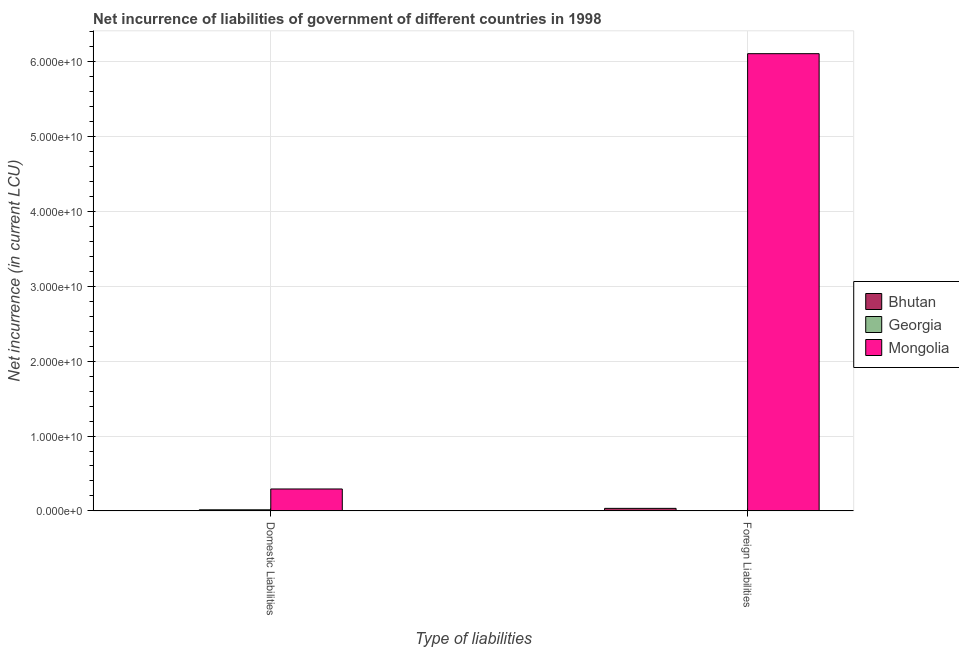Are the number of bars per tick equal to the number of legend labels?
Ensure brevity in your answer.  No. How many bars are there on the 2nd tick from the left?
Offer a very short reply. 3. How many bars are there on the 2nd tick from the right?
Keep it short and to the point. 2. What is the label of the 2nd group of bars from the left?
Provide a succinct answer. Foreign Liabilities. What is the net incurrence of domestic liabilities in Georgia?
Your answer should be very brief. 1.46e+08. Across all countries, what is the maximum net incurrence of domestic liabilities?
Offer a terse response. 2.93e+09. Across all countries, what is the minimum net incurrence of foreign liabilities?
Your response must be concise. 2.99e+07. In which country was the net incurrence of foreign liabilities maximum?
Keep it short and to the point. Mongolia. What is the total net incurrence of domestic liabilities in the graph?
Provide a short and direct response. 3.07e+09. What is the difference between the net incurrence of foreign liabilities in Georgia and that in Bhutan?
Make the answer very short. -3.06e+08. What is the difference between the net incurrence of foreign liabilities in Mongolia and the net incurrence of domestic liabilities in Georgia?
Offer a terse response. 6.09e+1. What is the average net incurrence of domestic liabilities per country?
Give a very brief answer. 1.02e+09. What is the difference between the net incurrence of foreign liabilities and net incurrence of domestic liabilities in Mongolia?
Offer a very short reply. 5.82e+1. What is the ratio of the net incurrence of foreign liabilities in Mongolia to that in Georgia?
Provide a short and direct response. 2042.94. Is the net incurrence of foreign liabilities in Mongolia less than that in Bhutan?
Make the answer very short. No. In how many countries, is the net incurrence of foreign liabilities greater than the average net incurrence of foreign liabilities taken over all countries?
Ensure brevity in your answer.  1. Are all the bars in the graph horizontal?
Give a very brief answer. No. What is the difference between two consecutive major ticks on the Y-axis?
Ensure brevity in your answer.  1.00e+1. Does the graph contain any zero values?
Offer a very short reply. Yes. How are the legend labels stacked?
Your answer should be very brief. Vertical. What is the title of the graph?
Give a very brief answer. Net incurrence of liabilities of government of different countries in 1998. Does "Malta" appear as one of the legend labels in the graph?
Your response must be concise. No. What is the label or title of the X-axis?
Your answer should be compact. Type of liabilities. What is the label or title of the Y-axis?
Your answer should be compact. Net incurrence (in current LCU). What is the Net incurrence (in current LCU) in Bhutan in Domestic Liabilities?
Offer a terse response. 0. What is the Net incurrence (in current LCU) in Georgia in Domestic Liabilities?
Make the answer very short. 1.46e+08. What is the Net incurrence (in current LCU) in Mongolia in Domestic Liabilities?
Ensure brevity in your answer.  2.93e+09. What is the Net incurrence (in current LCU) of Bhutan in Foreign Liabilities?
Offer a terse response. 3.36e+08. What is the Net incurrence (in current LCU) of Georgia in Foreign Liabilities?
Offer a very short reply. 2.99e+07. What is the Net incurrence (in current LCU) of Mongolia in Foreign Liabilities?
Your answer should be compact. 6.11e+1. Across all Type of liabilities, what is the maximum Net incurrence (in current LCU) in Bhutan?
Your answer should be very brief. 3.36e+08. Across all Type of liabilities, what is the maximum Net incurrence (in current LCU) in Georgia?
Offer a terse response. 1.46e+08. Across all Type of liabilities, what is the maximum Net incurrence (in current LCU) of Mongolia?
Offer a terse response. 6.11e+1. Across all Type of liabilities, what is the minimum Net incurrence (in current LCU) in Bhutan?
Your answer should be compact. 0. Across all Type of liabilities, what is the minimum Net incurrence (in current LCU) of Georgia?
Your answer should be very brief. 2.99e+07. Across all Type of liabilities, what is the minimum Net incurrence (in current LCU) in Mongolia?
Give a very brief answer. 2.93e+09. What is the total Net incurrence (in current LCU) of Bhutan in the graph?
Offer a terse response. 3.36e+08. What is the total Net incurrence (in current LCU) of Georgia in the graph?
Provide a succinct answer. 1.75e+08. What is the total Net incurrence (in current LCU) in Mongolia in the graph?
Your answer should be compact. 6.40e+1. What is the difference between the Net incurrence (in current LCU) of Georgia in Domestic Liabilities and that in Foreign Liabilities?
Give a very brief answer. 1.16e+08. What is the difference between the Net incurrence (in current LCU) of Mongolia in Domestic Liabilities and that in Foreign Liabilities?
Offer a terse response. -5.82e+1. What is the difference between the Net incurrence (in current LCU) of Georgia in Domestic Liabilities and the Net incurrence (in current LCU) of Mongolia in Foreign Liabilities?
Give a very brief answer. -6.09e+1. What is the average Net incurrence (in current LCU) in Bhutan per Type of liabilities?
Your answer should be compact. 1.68e+08. What is the average Net incurrence (in current LCU) of Georgia per Type of liabilities?
Ensure brevity in your answer.  8.77e+07. What is the average Net incurrence (in current LCU) in Mongolia per Type of liabilities?
Ensure brevity in your answer.  3.20e+1. What is the difference between the Net incurrence (in current LCU) of Georgia and Net incurrence (in current LCU) of Mongolia in Domestic Liabilities?
Your response must be concise. -2.78e+09. What is the difference between the Net incurrence (in current LCU) in Bhutan and Net incurrence (in current LCU) in Georgia in Foreign Liabilities?
Provide a short and direct response. 3.06e+08. What is the difference between the Net incurrence (in current LCU) of Bhutan and Net incurrence (in current LCU) of Mongolia in Foreign Liabilities?
Offer a very short reply. -6.07e+1. What is the difference between the Net incurrence (in current LCU) in Georgia and Net incurrence (in current LCU) in Mongolia in Foreign Liabilities?
Offer a terse response. -6.11e+1. What is the ratio of the Net incurrence (in current LCU) of Georgia in Domestic Liabilities to that in Foreign Liabilities?
Give a very brief answer. 4.87. What is the ratio of the Net incurrence (in current LCU) in Mongolia in Domestic Liabilities to that in Foreign Liabilities?
Your answer should be compact. 0.05. What is the difference between the highest and the second highest Net incurrence (in current LCU) of Georgia?
Keep it short and to the point. 1.16e+08. What is the difference between the highest and the second highest Net incurrence (in current LCU) of Mongolia?
Give a very brief answer. 5.82e+1. What is the difference between the highest and the lowest Net incurrence (in current LCU) in Bhutan?
Your answer should be compact. 3.36e+08. What is the difference between the highest and the lowest Net incurrence (in current LCU) in Georgia?
Ensure brevity in your answer.  1.16e+08. What is the difference between the highest and the lowest Net incurrence (in current LCU) in Mongolia?
Your answer should be compact. 5.82e+1. 